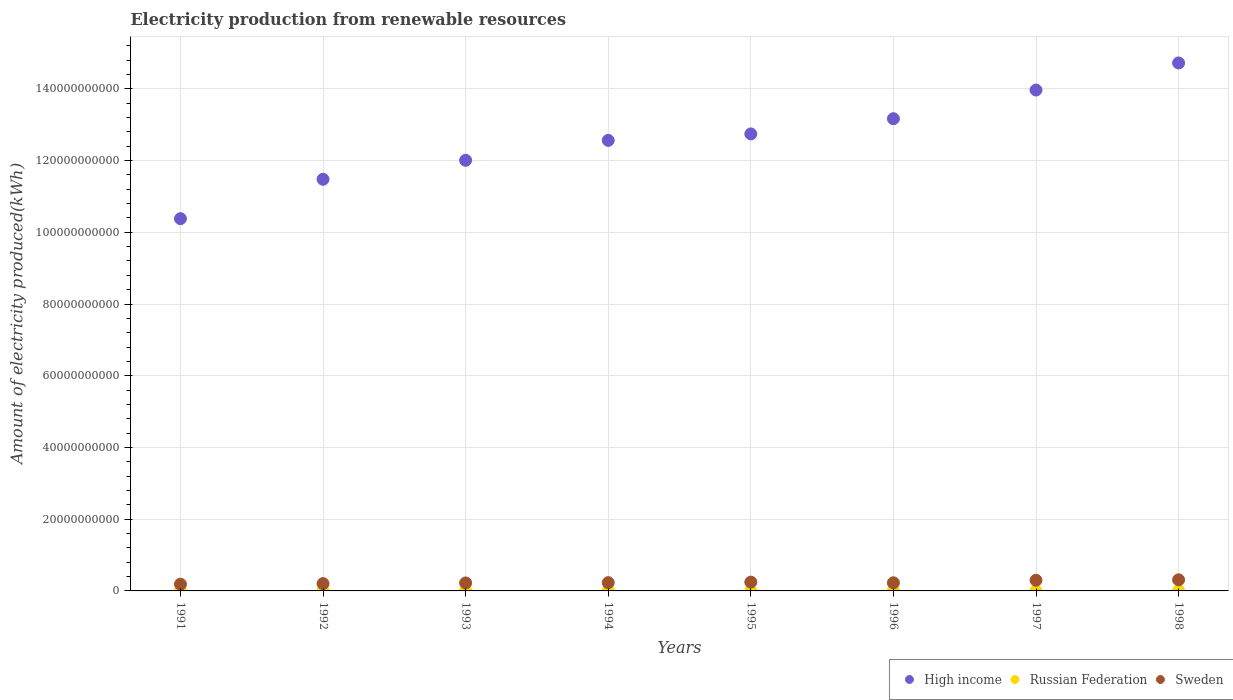Is the number of dotlines equal to the number of legend labels?
Offer a terse response. Yes. What is the amount of electricity produced in Russian Federation in 1998?
Offer a terse response. 5.80e+07. Across all years, what is the maximum amount of electricity produced in Russian Federation?
Make the answer very short. 6.50e+07. Across all years, what is the minimum amount of electricity produced in Sweden?
Your answer should be compact. 1.87e+09. In which year was the amount of electricity produced in Russian Federation maximum?
Give a very brief answer. 1991. In which year was the amount of electricity produced in Russian Federation minimum?
Give a very brief answer. 1996. What is the total amount of electricity produced in Sweden in the graph?
Keep it short and to the point. 1.92e+1. What is the difference between the amount of electricity produced in High income in 1992 and that in 1995?
Give a very brief answer. -1.27e+1. What is the difference between the amount of electricity produced in Russian Federation in 1995 and the amount of electricity produced in Sweden in 1996?
Give a very brief answer. -2.20e+09. What is the average amount of electricity produced in Sweden per year?
Provide a succinct answer. 2.40e+09. In the year 1998, what is the difference between the amount of electricity produced in Russian Federation and amount of electricity produced in High income?
Make the answer very short. -1.47e+11. In how many years, is the amount of electricity produced in Russian Federation greater than 16000000000 kWh?
Keep it short and to the point. 0. What is the ratio of the amount of electricity produced in Sweden in 1997 to that in 1998?
Ensure brevity in your answer.  0.96. Is the amount of electricity produced in Russian Federation in 1993 less than that in 1996?
Provide a short and direct response. No. What is the difference between the highest and the second highest amount of electricity produced in High income?
Your answer should be very brief. 7.55e+09. What is the difference between the highest and the lowest amount of electricity produced in Sweden?
Your response must be concise. 1.22e+09. Is the sum of the amount of electricity produced in Sweden in 1993 and 1997 greater than the maximum amount of electricity produced in Russian Federation across all years?
Your response must be concise. Yes. Where does the legend appear in the graph?
Provide a succinct answer. Bottom right. What is the title of the graph?
Your answer should be compact. Electricity production from renewable resources. Does "Cabo Verde" appear as one of the legend labels in the graph?
Give a very brief answer. No. What is the label or title of the Y-axis?
Make the answer very short. Amount of electricity produced(kWh). What is the Amount of electricity produced(kWh) in High income in 1991?
Your response must be concise. 1.04e+11. What is the Amount of electricity produced(kWh) in Russian Federation in 1991?
Provide a short and direct response. 6.50e+07. What is the Amount of electricity produced(kWh) of Sweden in 1991?
Offer a very short reply. 1.87e+09. What is the Amount of electricity produced(kWh) of High income in 1992?
Provide a succinct answer. 1.15e+11. What is the Amount of electricity produced(kWh) of Russian Federation in 1992?
Offer a very short reply. 6.30e+07. What is the Amount of electricity produced(kWh) of Sweden in 1992?
Your answer should be compact. 2.04e+09. What is the Amount of electricity produced(kWh) in High income in 1993?
Provide a succinct answer. 1.20e+11. What is the Amount of electricity produced(kWh) in Russian Federation in 1993?
Your answer should be very brief. 6.00e+07. What is the Amount of electricity produced(kWh) in Sweden in 1993?
Keep it short and to the point. 2.22e+09. What is the Amount of electricity produced(kWh) in High income in 1994?
Make the answer very short. 1.26e+11. What is the Amount of electricity produced(kWh) in Russian Federation in 1994?
Give a very brief answer. 6.10e+07. What is the Amount of electricity produced(kWh) of Sweden in 1994?
Offer a terse response. 2.30e+09. What is the Amount of electricity produced(kWh) in High income in 1995?
Give a very brief answer. 1.27e+11. What is the Amount of electricity produced(kWh) of Russian Federation in 1995?
Your answer should be compact. 5.90e+07. What is the Amount of electricity produced(kWh) in Sweden in 1995?
Provide a succinct answer. 2.45e+09. What is the Amount of electricity produced(kWh) of High income in 1996?
Your answer should be very brief. 1.32e+11. What is the Amount of electricity produced(kWh) of Russian Federation in 1996?
Your answer should be very brief. 5.70e+07. What is the Amount of electricity produced(kWh) of Sweden in 1996?
Make the answer very short. 2.26e+09. What is the Amount of electricity produced(kWh) of High income in 1997?
Offer a very short reply. 1.40e+11. What is the Amount of electricity produced(kWh) of Russian Federation in 1997?
Make the answer very short. 5.70e+07. What is the Amount of electricity produced(kWh) in Sweden in 1997?
Ensure brevity in your answer.  2.98e+09. What is the Amount of electricity produced(kWh) of High income in 1998?
Offer a very short reply. 1.47e+11. What is the Amount of electricity produced(kWh) in Russian Federation in 1998?
Offer a very short reply. 5.80e+07. What is the Amount of electricity produced(kWh) in Sweden in 1998?
Keep it short and to the point. 3.10e+09. Across all years, what is the maximum Amount of electricity produced(kWh) of High income?
Give a very brief answer. 1.47e+11. Across all years, what is the maximum Amount of electricity produced(kWh) in Russian Federation?
Make the answer very short. 6.50e+07. Across all years, what is the maximum Amount of electricity produced(kWh) in Sweden?
Your answer should be very brief. 3.10e+09. Across all years, what is the minimum Amount of electricity produced(kWh) of High income?
Your answer should be compact. 1.04e+11. Across all years, what is the minimum Amount of electricity produced(kWh) in Russian Federation?
Your response must be concise. 5.70e+07. Across all years, what is the minimum Amount of electricity produced(kWh) of Sweden?
Offer a terse response. 1.87e+09. What is the total Amount of electricity produced(kWh) of High income in the graph?
Offer a terse response. 1.01e+12. What is the total Amount of electricity produced(kWh) of Russian Federation in the graph?
Give a very brief answer. 4.80e+08. What is the total Amount of electricity produced(kWh) of Sweden in the graph?
Make the answer very short. 1.92e+1. What is the difference between the Amount of electricity produced(kWh) of High income in 1991 and that in 1992?
Your response must be concise. -1.10e+1. What is the difference between the Amount of electricity produced(kWh) of Russian Federation in 1991 and that in 1992?
Make the answer very short. 2.00e+06. What is the difference between the Amount of electricity produced(kWh) in Sweden in 1991 and that in 1992?
Ensure brevity in your answer.  -1.68e+08. What is the difference between the Amount of electricity produced(kWh) of High income in 1991 and that in 1993?
Your answer should be very brief. -1.63e+1. What is the difference between the Amount of electricity produced(kWh) in Sweden in 1991 and that in 1993?
Keep it short and to the point. -3.47e+08. What is the difference between the Amount of electricity produced(kWh) of High income in 1991 and that in 1994?
Make the answer very short. -2.18e+1. What is the difference between the Amount of electricity produced(kWh) of Sweden in 1991 and that in 1994?
Make the answer very short. -4.29e+08. What is the difference between the Amount of electricity produced(kWh) in High income in 1991 and that in 1995?
Your answer should be very brief. -2.36e+1. What is the difference between the Amount of electricity produced(kWh) in Russian Federation in 1991 and that in 1995?
Your response must be concise. 6.00e+06. What is the difference between the Amount of electricity produced(kWh) in Sweden in 1991 and that in 1995?
Your answer should be very brief. -5.81e+08. What is the difference between the Amount of electricity produced(kWh) of High income in 1991 and that in 1996?
Make the answer very short. -2.79e+1. What is the difference between the Amount of electricity produced(kWh) of Sweden in 1991 and that in 1996?
Your answer should be very brief. -3.90e+08. What is the difference between the Amount of electricity produced(kWh) in High income in 1991 and that in 1997?
Your answer should be compact. -3.59e+1. What is the difference between the Amount of electricity produced(kWh) in Sweden in 1991 and that in 1997?
Your response must be concise. -1.10e+09. What is the difference between the Amount of electricity produced(kWh) in High income in 1991 and that in 1998?
Provide a succinct answer. -4.34e+1. What is the difference between the Amount of electricity produced(kWh) of Russian Federation in 1991 and that in 1998?
Give a very brief answer. 7.00e+06. What is the difference between the Amount of electricity produced(kWh) in Sweden in 1991 and that in 1998?
Your answer should be compact. -1.22e+09. What is the difference between the Amount of electricity produced(kWh) of High income in 1992 and that in 1993?
Give a very brief answer. -5.29e+09. What is the difference between the Amount of electricity produced(kWh) of Russian Federation in 1992 and that in 1993?
Keep it short and to the point. 3.00e+06. What is the difference between the Amount of electricity produced(kWh) of Sweden in 1992 and that in 1993?
Give a very brief answer. -1.79e+08. What is the difference between the Amount of electricity produced(kWh) of High income in 1992 and that in 1994?
Your answer should be compact. -1.08e+1. What is the difference between the Amount of electricity produced(kWh) of Russian Federation in 1992 and that in 1994?
Keep it short and to the point. 2.00e+06. What is the difference between the Amount of electricity produced(kWh) of Sweden in 1992 and that in 1994?
Offer a terse response. -2.61e+08. What is the difference between the Amount of electricity produced(kWh) of High income in 1992 and that in 1995?
Offer a terse response. -1.27e+1. What is the difference between the Amount of electricity produced(kWh) of Sweden in 1992 and that in 1995?
Give a very brief answer. -4.13e+08. What is the difference between the Amount of electricity produced(kWh) of High income in 1992 and that in 1996?
Give a very brief answer. -1.69e+1. What is the difference between the Amount of electricity produced(kWh) in Russian Federation in 1992 and that in 1996?
Offer a terse response. 6.00e+06. What is the difference between the Amount of electricity produced(kWh) in Sweden in 1992 and that in 1996?
Ensure brevity in your answer.  -2.22e+08. What is the difference between the Amount of electricity produced(kWh) of High income in 1992 and that in 1997?
Make the answer very short. -2.49e+1. What is the difference between the Amount of electricity produced(kWh) of Sweden in 1992 and that in 1997?
Keep it short and to the point. -9.36e+08. What is the difference between the Amount of electricity produced(kWh) in High income in 1992 and that in 1998?
Keep it short and to the point. -3.24e+1. What is the difference between the Amount of electricity produced(kWh) in Russian Federation in 1992 and that in 1998?
Offer a very short reply. 5.00e+06. What is the difference between the Amount of electricity produced(kWh) in Sweden in 1992 and that in 1998?
Provide a short and direct response. -1.06e+09. What is the difference between the Amount of electricity produced(kWh) of High income in 1993 and that in 1994?
Make the answer very short. -5.56e+09. What is the difference between the Amount of electricity produced(kWh) of Russian Federation in 1993 and that in 1994?
Give a very brief answer. -1.00e+06. What is the difference between the Amount of electricity produced(kWh) of Sweden in 1993 and that in 1994?
Ensure brevity in your answer.  -8.20e+07. What is the difference between the Amount of electricity produced(kWh) in High income in 1993 and that in 1995?
Keep it short and to the point. -7.36e+09. What is the difference between the Amount of electricity produced(kWh) of Sweden in 1993 and that in 1995?
Make the answer very short. -2.34e+08. What is the difference between the Amount of electricity produced(kWh) of High income in 1993 and that in 1996?
Provide a short and direct response. -1.16e+1. What is the difference between the Amount of electricity produced(kWh) in Sweden in 1993 and that in 1996?
Provide a short and direct response. -4.30e+07. What is the difference between the Amount of electricity produced(kWh) in High income in 1993 and that in 1997?
Provide a short and direct response. -1.96e+1. What is the difference between the Amount of electricity produced(kWh) of Sweden in 1993 and that in 1997?
Your answer should be compact. -7.57e+08. What is the difference between the Amount of electricity produced(kWh) in High income in 1993 and that in 1998?
Keep it short and to the point. -2.71e+1. What is the difference between the Amount of electricity produced(kWh) in Sweden in 1993 and that in 1998?
Provide a succinct answer. -8.78e+08. What is the difference between the Amount of electricity produced(kWh) of High income in 1994 and that in 1995?
Your answer should be compact. -1.80e+09. What is the difference between the Amount of electricity produced(kWh) of Sweden in 1994 and that in 1995?
Your answer should be compact. -1.52e+08. What is the difference between the Amount of electricity produced(kWh) in High income in 1994 and that in 1996?
Offer a terse response. -6.05e+09. What is the difference between the Amount of electricity produced(kWh) of Russian Federation in 1994 and that in 1996?
Your answer should be very brief. 4.00e+06. What is the difference between the Amount of electricity produced(kWh) in Sweden in 1994 and that in 1996?
Your answer should be very brief. 3.90e+07. What is the difference between the Amount of electricity produced(kWh) of High income in 1994 and that in 1997?
Your response must be concise. -1.40e+1. What is the difference between the Amount of electricity produced(kWh) of Russian Federation in 1994 and that in 1997?
Provide a succinct answer. 4.00e+06. What is the difference between the Amount of electricity produced(kWh) of Sweden in 1994 and that in 1997?
Your answer should be compact. -6.75e+08. What is the difference between the Amount of electricity produced(kWh) in High income in 1994 and that in 1998?
Provide a short and direct response. -2.16e+1. What is the difference between the Amount of electricity produced(kWh) in Russian Federation in 1994 and that in 1998?
Give a very brief answer. 3.00e+06. What is the difference between the Amount of electricity produced(kWh) in Sweden in 1994 and that in 1998?
Offer a very short reply. -7.96e+08. What is the difference between the Amount of electricity produced(kWh) of High income in 1995 and that in 1996?
Give a very brief answer. -4.24e+09. What is the difference between the Amount of electricity produced(kWh) of Sweden in 1995 and that in 1996?
Provide a succinct answer. 1.91e+08. What is the difference between the Amount of electricity produced(kWh) in High income in 1995 and that in 1997?
Your answer should be compact. -1.22e+1. What is the difference between the Amount of electricity produced(kWh) in Russian Federation in 1995 and that in 1997?
Provide a succinct answer. 2.00e+06. What is the difference between the Amount of electricity produced(kWh) of Sweden in 1995 and that in 1997?
Offer a very short reply. -5.23e+08. What is the difference between the Amount of electricity produced(kWh) in High income in 1995 and that in 1998?
Your answer should be compact. -1.98e+1. What is the difference between the Amount of electricity produced(kWh) of Sweden in 1995 and that in 1998?
Give a very brief answer. -6.44e+08. What is the difference between the Amount of electricity produced(kWh) in High income in 1996 and that in 1997?
Your response must be concise. -7.99e+09. What is the difference between the Amount of electricity produced(kWh) of Russian Federation in 1996 and that in 1997?
Your answer should be compact. 0. What is the difference between the Amount of electricity produced(kWh) in Sweden in 1996 and that in 1997?
Provide a succinct answer. -7.14e+08. What is the difference between the Amount of electricity produced(kWh) in High income in 1996 and that in 1998?
Your answer should be very brief. -1.55e+1. What is the difference between the Amount of electricity produced(kWh) in Russian Federation in 1996 and that in 1998?
Make the answer very short. -1.00e+06. What is the difference between the Amount of electricity produced(kWh) in Sweden in 1996 and that in 1998?
Your response must be concise. -8.35e+08. What is the difference between the Amount of electricity produced(kWh) of High income in 1997 and that in 1998?
Make the answer very short. -7.55e+09. What is the difference between the Amount of electricity produced(kWh) in Russian Federation in 1997 and that in 1998?
Make the answer very short. -1.00e+06. What is the difference between the Amount of electricity produced(kWh) in Sweden in 1997 and that in 1998?
Your answer should be compact. -1.21e+08. What is the difference between the Amount of electricity produced(kWh) of High income in 1991 and the Amount of electricity produced(kWh) of Russian Federation in 1992?
Your answer should be compact. 1.04e+11. What is the difference between the Amount of electricity produced(kWh) in High income in 1991 and the Amount of electricity produced(kWh) in Sweden in 1992?
Your answer should be very brief. 1.02e+11. What is the difference between the Amount of electricity produced(kWh) in Russian Federation in 1991 and the Amount of electricity produced(kWh) in Sweden in 1992?
Ensure brevity in your answer.  -1.98e+09. What is the difference between the Amount of electricity produced(kWh) in High income in 1991 and the Amount of electricity produced(kWh) in Russian Federation in 1993?
Offer a very short reply. 1.04e+11. What is the difference between the Amount of electricity produced(kWh) in High income in 1991 and the Amount of electricity produced(kWh) in Sweden in 1993?
Provide a succinct answer. 1.02e+11. What is the difference between the Amount of electricity produced(kWh) of Russian Federation in 1991 and the Amount of electricity produced(kWh) of Sweden in 1993?
Keep it short and to the point. -2.16e+09. What is the difference between the Amount of electricity produced(kWh) of High income in 1991 and the Amount of electricity produced(kWh) of Russian Federation in 1994?
Ensure brevity in your answer.  1.04e+11. What is the difference between the Amount of electricity produced(kWh) of High income in 1991 and the Amount of electricity produced(kWh) of Sweden in 1994?
Your response must be concise. 1.01e+11. What is the difference between the Amount of electricity produced(kWh) in Russian Federation in 1991 and the Amount of electricity produced(kWh) in Sweden in 1994?
Offer a terse response. -2.24e+09. What is the difference between the Amount of electricity produced(kWh) in High income in 1991 and the Amount of electricity produced(kWh) in Russian Federation in 1995?
Your answer should be compact. 1.04e+11. What is the difference between the Amount of electricity produced(kWh) in High income in 1991 and the Amount of electricity produced(kWh) in Sweden in 1995?
Provide a succinct answer. 1.01e+11. What is the difference between the Amount of electricity produced(kWh) of Russian Federation in 1991 and the Amount of electricity produced(kWh) of Sweden in 1995?
Give a very brief answer. -2.39e+09. What is the difference between the Amount of electricity produced(kWh) of High income in 1991 and the Amount of electricity produced(kWh) of Russian Federation in 1996?
Offer a terse response. 1.04e+11. What is the difference between the Amount of electricity produced(kWh) of High income in 1991 and the Amount of electricity produced(kWh) of Sweden in 1996?
Your response must be concise. 1.02e+11. What is the difference between the Amount of electricity produced(kWh) in Russian Federation in 1991 and the Amount of electricity produced(kWh) in Sweden in 1996?
Your answer should be compact. -2.20e+09. What is the difference between the Amount of electricity produced(kWh) in High income in 1991 and the Amount of electricity produced(kWh) in Russian Federation in 1997?
Ensure brevity in your answer.  1.04e+11. What is the difference between the Amount of electricity produced(kWh) in High income in 1991 and the Amount of electricity produced(kWh) in Sweden in 1997?
Provide a short and direct response. 1.01e+11. What is the difference between the Amount of electricity produced(kWh) of Russian Federation in 1991 and the Amount of electricity produced(kWh) of Sweden in 1997?
Your answer should be compact. -2.91e+09. What is the difference between the Amount of electricity produced(kWh) of High income in 1991 and the Amount of electricity produced(kWh) of Russian Federation in 1998?
Keep it short and to the point. 1.04e+11. What is the difference between the Amount of electricity produced(kWh) in High income in 1991 and the Amount of electricity produced(kWh) in Sweden in 1998?
Ensure brevity in your answer.  1.01e+11. What is the difference between the Amount of electricity produced(kWh) of Russian Federation in 1991 and the Amount of electricity produced(kWh) of Sweden in 1998?
Your answer should be compact. -3.03e+09. What is the difference between the Amount of electricity produced(kWh) of High income in 1992 and the Amount of electricity produced(kWh) of Russian Federation in 1993?
Provide a short and direct response. 1.15e+11. What is the difference between the Amount of electricity produced(kWh) in High income in 1992 and the Amount of electricity produced(kWh) in Sweden in 1993?
Your answer should be very brief. 1.13e+11. What is the difference between the Amount of electricity produced(kWh) of Russian Federation in 1992 and the Amount of electricity produced(kWh) of Sweden in 1993?
Your response must be concise. -2.16e+09. What is the difference between the Amount of electricity produced(kWh) of High income in 1992 and the Amount of electricity produced(kWh) of Russian Federation in 1994?
Offer a terse response. 1.15e+11. What is the difference between the Amount of electricity produced(kWh) of High income in 1992 and the Amount of electricity produced(kWh) of Sweden in 1994?
Provide a short and direct response. 1.12e+11. What is the difference between the Amount of electricity produced(kWh) in Russian Federation in 1992 and the Amount of electricity produced(kWh) in Sweden in 1994?
Keep it short and to the point. -2.24e+09. What is the difference between the Amount of electricity produced(kWh) in High income in 1992 and the Amount of electricity produced(kWh) in Russian Federation in 1995?
Offer a terse response. 1.15e+11. What is the difference between the Amount of electricity produced(kWh) in High income in 1992 and the Amount of electricity produced(kWh) in Sweden in 1995?
Keep it short and to the point. 1.12e+11. What is the difference between the Amount of electricity produced(kWh) of Russian Federation in 1992 and the Amount of electricity produced(kWh) of Sweden in 1995?
Your answer should be compact. -2.39e+09. What is the difference between the Amount of electricity produced(kWh) in High income in 1992 and the Amount of electricity produced(kWh) in Russian Federation in 1996?
Your response must be concise. 1.15e+11. What is the difference between the Amount of electricity produced(kWh) in High income in 1992 and the Amount of electricity produced(kWh) in Sweden in 1996?
Offer a terse response. 1.13e+11. What is the difference between the Amount of electricity produced(kWh) of Russian Federation in 1992 and the Amount of electricity produced(kWh) of Sweden in 1996?
Make the answer very short. -2.20e+09. What is the difference between the Amount of electricity produced(kWh) of High income in 1992 and the Amount of electricity produced(kWh) of Russian Federation in 1997?
Ensure brevity in your answer.  1.15e+11. What is the difference between the Amount of electricity produced(kWh) of High income in 1992 and the Amount of electricity produced(kWh) of Sweden in 1997?
Offer a very short reply. 1.12e+11. What is the difference between the Amount of electricity produced(kWh) of Russian Federation in 1992 and the Amount of electricity produced(kWh) of Sweden in 1997?
Give a very brief answer. -2.91e+09. What is the difference between the Amount of electricity produced(kWh) of High income in 1992 and the Amount of electricity produced(kWh) of Russian Federation in 1998?
Give a very brief answer. 1.15e+11. What is the difference between the Amount of electricity produced(kWh) in High income in 1992 and the Amount of electricity produced(kWh) in Sweden in 1998?
Your answer should be compact. 1.12e+11. What is the difference between the Amount of electricity produced(kWh) in Russian Federation in 1992 and the Amount of electricity produced(kWh) in Sweden in 1998?
Your answer should be compact. -3.04e+09. What is the difference between the Amount of electricity produced(kWh) of High income in 1993 and the Amount of electricity produced(kWh) of Russian Federation in 1994?
Provide a succinct answer. 1.20e+11. What is the difference between the Amount of electricity produced(kWh) of High income in 1993 and the Amount of electricity produced(kWh) of Sweden in 1994?
Give a very brief answer. 1.18e+11. What is the difference between the Amount of electricity produced(kWh) in Russian Federation in 1993 and the Amount of electricity produced(kWh) in Sweden in 1994?
Offer a very short reply. -2.24e+09. What is the difference between the Amount of electricity produced(kWh) in High income in 1993 and the Amount of electricity produced(kWh) in Russian Federation in 1995?
Your response must be concise. 1.20e+11. What is the difference between the Amount of electricity produced(kWh) of High income in 1993 and the Amount of electricity produced(kWh) of Sweden in 1995?
Your response must be concise. 1.18e+11. What is the difference between the Amount of electricity produced(kWh) of Russian Federation in 1993 and the Amount of electricity produced(kWh) of Sweden in 1995?
Offer a very short reply. -2.39e+09. What is the difference between the Amount of electricity produced(kWh) in High income in 1993 and the Amount of electricity produced(kWh) in Russian Federation in 1996?
Give a very brief answer. 1.20e+11. What is the difference between the Amount of electricity produced(kWh) in High income in 1993 and the Amount of electricity produced(kWh) in Sweden in 1996?
Provide a succinct answer. 1.18e+11. What is the difference between the Amount of electricity produced(kWh) of Russian Federation in 1993 and the Amount of electricity produced(kWh) of Sweden in 1996?
Provide a succinct answer. -2.20e+09. What is the difference between the Amount of electricity produced(kWh) in High income in 1993 and the Amount of electricity produced(kWh) in Russian Federation in 1997?
Your response must be concise. 1.20e+11. What is the difference between the Amount of electricity produced(kWh) of High income in 1993 and the Amount of electricity produced(kWh) of Sweden in 1997?
Give a very brief answer. 1.17e+11. What is the difference between the Amount of electricity produced(kWh) in Russian Federation in 1993 and the Amount of electricity produced(kWh) in Sweden in 1997?
Offer a very short reply. -2.92e+09. What is the difference between the Amount of electricity produced(kWh) of High income in 1993 and the Amount of electricity produced(kWh) of Russian Federation in 1998?
Provide a succinct answer. 1.20e+11. What is the difference between the Amount of electricity produced(kWh) in High income in 1993 and the Amount of electricity produced(kWh) in Sweden in 1998?
Keep it short and to the point. 1.17e+11. What is the difference between the Amount of electricity produced(kWh) of Russian Federation in 1993 and the Amount of electricity produced(kWh) of Sweden in 1998?
Give a very brief answer. -3.04e+09. What is the difference between the Amount of electricity produced(kWh) of High income in 1994 and the Amount of electricity produced(kWh) of Russian Federation in 1995?
Your answer should be compact. 1.26e+11. What is the difference between the Amount of electricity produced(kWh) in High income in 1994 and the Amount of electricity produced(kWh) in Sweden in 1995?
Your answer should be compact. 1.23e+11. What is the difference between the Amount of electricity produced(kWh) of Russian Federation in 1994 and the Amount of electricity produced(kWh) of Sweden in 1995?
Make the answer very short. -2.39e+09. What is the difference between the Amount of electricity produced(kWh) of High income in 1994 and the Amount of electricity produced(kWh) of Russian Federation in 1996?
Make the answer very short. 1.26e+11. What is the difference between the Amount of electricity produced(kWh) of High income in 1994 and the Amount of electricity produced(kWh) of Sweden in 1996?
Offer a terse response. 1.23e+11. What is the difference between the Amount of electricity produced(kWh) of Russian Federation in 1994 and the Amount of electricity produced(kWh) of Sweden in 1996?
Your answer should be compact. -2.20e+09. What is the difference between the Amount of electricity produced(kWh) of High income in 1994 and the Amount of electricity produced(kWh) of Russian Federation in 1997?
Offer a terse response. 1.26e+11. What is the difference between the Amount of electricity produced(kWh) in High income in 1994 and the Amount of electricity produced(kWh) in Sweden in 1997?
Ensure brevity in your answer.  1.23e+11. What is the difference between the Amount of electricity produced(kWh) in Russian Federation in 1994 and the Amount of electricity produced(kWh) in Sweden in 1997?
Your answer should be compact. -2.92e+09. What is the difference between the Amount of electricity produced(kWh) in High income in 1994 and the Amount of electricity produced(kWh) in Russian Federation in 1998?
Ensure brevity in your answer.  1.26e+11. What is the difference between the Amount of electricity produced(kWh) in High income in 1994 and the Amount of electricity produced(kWh) in Sweden in 1998?
Provide a succinct answer. 1.23e+11. What is the difference between the Amount of electricity produced(kWh) of Russian Federation in 1994 and the Amount of electricity produced(kWh) of Sweden in 1998?
Your answer should be very brief. -3.04e+09. What is the difference between the Amount of electricity produced(kWh) in High income in 1995 and the Amount of electricity produced(kWh) in Russian Federation in 1996?
Offer a very short reply. 1.27e+11. What is the difference between the Amount of electricity produced(kWh) of High income in 1995 and the Amount of electricity produced(kWh) of Sweden in 1996?
Provide a short and direct response. 1.25e+11. What is the difference between the Amount of electricity produced(kWh) in Russian Federation in 1995 and the Amount of electricity produced(kWh) in Sweden in 1996?
Your answer should be very brief. -2.20e+09. What is the difference between the Amount of electricity produced(kWh) of High income in 1995 and the Amount of electricity produced(kWh) of Russian Federation in 1997?
Offer a terse response. 1.27e+11. What is the difference between the Amount of electricity produced(kWh) of High income in 1995 and the Amount of electricity produced(kWh) of Sweden in 1997?
Make the answer very short. 1.24e+11. What is the difference between the Amount of electricity produced(kWh) of Russian Federation in 1995 and the Amount of electricity produced(kWh) of Sweden in 1997?
Your answer should be compact. -2.92e+09. What is the difference between the Amount of electricity produced(kWh) in High income in 1995 and the Amount of electricity produced(kWh) in Russian Federation in 1998?
Keep it short and to the point. 1.27e+11. What is the difference between the Amount of electricity produced(kWh) of High income in 1995 and the Amount of electricity produced(kWh) of Sweden in 1998?
Give a very brief answer. 1.24e+11. What is the difference between the Amount of electricity produced(kWh) in Russian Federation in 1995 and the Amount of electricity produced(kWh) in Sweden in 1998?
Offer a terse response. -3.04e+09. What is the difference between the Amount of electricity produced(kWh) of High income in 1996 and the Amount of electricity produced(kWh) of Russian Federation in 1997?
Keep it short and to the point. 1.32e+11. What is the difference between the Amount of electricity produced(kWh) in High income in 1996 and the Amount of electricity produced(kWh) in Sweden in 1997?
Offer a terse response. 1.29e+11. What is the difference between the Amount of electricity produced(kWh) in Russian Federation in 1996 and the Amount of electricity produced(kWh) in Sweden in 1997?
Give a very brief answer. -2.92e+09. What is the difference between the Amount of electricity produced(kWh) in High income in 1996 and the Amount of electricity produced(kWh) in Russian Federation in 1998?
Your response must be concise. 1.32e+11. What is the difference between the Amount of electricity produced(kWh) of High income in 1996 and the Amount of electricity produced(kWh) of Sweden in 1998?
Offer a terse response. 1.29e+11. What is the difference between the Amount of electricity produced(kWh) of Russian Federation in 1996 and the Amount of electricity produced(kWh) of Sweden in 1998?
Provide a short and direct response. -3.04e+09. What is the difference between the Amount of electricity produced(kWh) of High income in 1997 and the Amount of electricity produced(kWh) of Russian Federation in 1998?
Offer a terse response. 1.40e+11. What is the difference between the Amount of electricity produced(kWh) in High income in 1997 and the Amount of electricity produced(kWh) in Sweden in 1998?
Provide a short and direct response. 1.37e+11. What is the difference between the Amount of electricity produced(kWh) in Russian Federation in 1997 and the Amount of electricity produced(kWh) in Sweden in 1998?
Offer a very short reply. -3.04e+09. What is the average Amount of electricity produced(kWh) in High income per year?
Your answer should be very brief. 1.26e+11. What is the average Amount of electricity produced(kWh) of Russian Federation per year?
Your response must be concise. 6.00e+07. What is the average Amount of electricity produced(kWh) of Sweden per year?
Offer a terse response. 2.40e+09. In the year 1991, what is the difference between the Amount of electricity produced(kWh) of High income and Amount of electricity produced(kWh) of Russian Federation?
Provide a short and direct response. 1.04e+11. In the year 1991, what is the difference between the Amount of electricity produced(kWh) of High income and Amount of electricity produced(kWh) of Sweden?
Your response must be concise. 1.02e+11. In the year 1991, what is the difference between the Amount of electricity produced(kWh) of Russian Federation and Amount of electricity produced(kWh) of Sweden?
Your answer should be compact. -1.81e+09. In the year 1992, what is the difference between the Amount of electricity produced(kWh) of High income and Amount of electricity produced(kWh) of Russian Federation?
Give a very brief answer. 1.15e+11. In the year 1992, what is the difference between the Amount of electricity produced(kWh) in High income and Amount of electricity produced(kWh) in Sweden?
Make the answer very short. 1.13e+11. In the year 1992, what is the difference between the Amount of electricity produced(kWh) in Russian Federation and Amount of electricity produced(kWh) in Sweden?
Keep it short and to the point. -1.98e+09. In the year 1993, what is the difference between the Amount of electricity produced(kWh) in High income and Amount of electricity produced(kWh) in Russian Federation?
Ensure brevity in your answer.  1.20e+11. In the year 1993, what is the difference between the Amount of electricity produced(kWh) of High income and Amount of electricity produced(kWh) of Sweden?
Ensure brevity in your answer.  1.18e+11. In the year 1993, what is the difference between the Amount of electricity produced(kWh) in Russian Federation and Amount of electricity produced(kWh) in Sweden?
Provide a short and direct response. -2.16e+09. In the year 1994, what is the difference between the Amount of electricity produced(kWh) in High income and Amount of electricity produced(kWh) in Russian Federation?
Ensure brevity in your answer.  1.26e+11. In the year 1994, what is the difference between the Amount of electricity produced(kWh) of High income and Amount of electricity produced(kWh) of Sweden?
Provide a succinct answer. 1.23e+11. In the year 1994, what is the difference between the Amount of electricity produced(kWh) in Russian Federation and Amount of electricity produced(kWh) in Sweden?
Offer a terse response. -2.24e+09. In the year 1995, what is the difference between the Amount of electricity produced(kWh) of High income and Amount of electricity produced(kWh) of Russian Federation?
Your answer should be compact. 1.27e+11. In the year 1995, what is the difference between the Amount of electricity produced(kWh) in High income and Amount of electricity produced(kWh) in Sweden?
Your response must be concise. 1.25e+11. In the year 1995, what is the difference between the Amount of electricity produced(kWh) in Russian Federation and Amount of electricity produced(kWh) in Sweden?
Your response must be concise. -2.40e+09. In the year 1996, what is the difference between the Amount of electricity produced(kWh) in High income and Amount of electricity produced(kWh) in Russian Federation?
Your answer should be very brief. 1.32e+11. In the year 1996, what is the difference between the Amount of electricity produced(kWh) in High income and Amount of electricity produced(kWh) in Sweden?
Make the answer very short. 1.29e+11. In the year 1996, what is the difference between the Amount of electricity produced(kWh) of Russian Federation and Amount of electricity produced(kWh) of Sweden?
Ensure brevity in your answer.  -2.21e+09. In the year 1997, what is the difference between the Amount of electricity produced(kWh) of High income and Amount of electricity produced(kWh) of Russian Federation?
Your answer should be very brief. 1.40e+11. In the year 1997, what is the difference between the Amount of electricity produced(kWh) of High income and Amount of electricity produced(kWh) of Sweden?
Offer a very short reply. 1.37e+11. In the year 1997, what is the difference between the Amount of electricity produced(kWh) in Russian Federation and Amount of electricity produced(kWh) in Sweden?
Provide a succinct answer. -2.92e+09. In the year 1998, what is the difference between the Amount of electricity produced(kWh) in High income and Amount of electricity produced(kWh) in Russian Federation?
Offer a very short reply. 1.47e+11. In the year 1998, what is the difference between the Amount of electricity produced(kWh) of High income and Amount of electricity produced(kWh) of Sweden?
Keep it short and to the point. 1.44e+11. In the year 1998, what is the difference between the Amount of electricity produced(kWh) in Russian Federation and Amount of electricity produced(kWh) in Sweden?
Offer a terse response. -3.04e+09. What is the ratio of the Amount of electricity produced(kWh) in High income in 1991 to that in 1992?
Provide a succinct answer. 0.9. What is the ratio of the Amount of electricity produced(kWh) in Russian Federation in 1991 to that in 1992?
Keep it short and to the point. 1.03. What is the ratio of the Amount of electricity produced(kWh) in Sweden in 1991 to that in 1992?
Ensure brevity in your answer.  0.92. What is the ratio of the Amount of electricity produced(kWh) in High income in 1991 to that in 1993?
Offer a very short reply. 0.86. What is the ratio of the Amount of electricity produced(kWh) in Russian Federation in 1991 to that in 1993?
Give a very brief answer. 1.08. What is the ratio of the Amount of electricity produced(kWh) of Sweden in 1991 to that in 1993?
Your response must be concise. 0.84. What is the ratio of the Amount of electricity produced(kWh) in High income in 1991 to that in 1994?
Offer a very short reply. 0.83. What is the ratio of the Amount of electricity produced(kWh) in Russian Federation in 1991 to that in 1994?
Your answer should be compact. 1.07. What is the ratio of the Amount of electricity produced(kWh) of Sweden in 1991 to that in 1994?
Give a very brief answer. 0.81. What is the ratio of the Amount of electricity produced(kWh) of High income in 1991 to that in 1995?
Ensure brevity in your answer.  0.81. What is the ratio of the Amount of electricity produced(kWh) in Russian Federation in 1991 to that in 1995?
Your answer should be very brief. 1.1. What is the ratio of the Amount of electricity produced(kWh) in Sweden in 1991 to that in 1995?
Your answer should be compact. 0.76. What is the ratio of the Amount of electricity produced(kWh) in High income in 1991 to that in 1996?
Provide a succinct answer. 0.79. What is the ratio of the Amount of electricity produced(kWh) in Russian Federation in 1991 to that in 1996?
Give a very brief answer. 1.14. What is the ratio of the Amount of electricity produced(kWh) of Sweden in 1991 to that in 1996?
Your answer should be compact. 0.83. What is the ratio of the Amount of electricity produced(kWh) in High income in 1991 to that in 1997?
Offer a very short reply. 0.74. What is the ratio of the Amount of electricity produced(kWh) in Russian Federation in 1991 to that in 1997?
Offer a very short reply. 1.14. What is the ratio of the Amount of electricity produced(kWh) in Sweden in 1991 to that in 1997?
Keep it short and to the point. 0.63. What is the ratio of the Amount of electricity produced(kWh) of High income in 1991 to that in 1998?
Make the answer very short. 0.71. What is the ratio of the Amount of electricity produced(kWh) of Russian Federation in 1991 to that in 1998?
Your response must be concise. 1.12. What is the ratio of the Amount of electricity produced(kWh) of Sweden in 1991 to that in 1998?
Your answer should be very brief. 0.6. What is the ratio of the Amount of electricity produced(kWh) of High income in 1992 to that in 1993?
Your response must be concise. 0.96. What is the ratio of the Amount of electricity produced(kWh) of Russian Federation in 1992 to that in 1993?
Offer a terse response. 1.05. What is the ratio of the Amount of electricity produced(kWh) of Sweden in 1992 to that in 1993?
Your answer should be compact. 0.92. What is the ratio of the Amount of electricity produced(kWh) of High income in 1992 to that in 1994?
Provide a short and direct response. 0.91. What is the ratio of the Amount of electricity produced(kWh) in Russian Federation in 1992 to that in 1994?
Offer a very short reply. 1.03. What is the ratio of the Amount of electricity produced(kWh) in Sweden in 1992 to that in 1994?
Offer a very short reply. 0.89. What is the ratio of the Amount of electricity produced(kWh) in High income in 1992 to that in 1995?
Give a very brief answer. 0.9. What is the ratio of the Amount of electricity produced(kWh) of Russian Federation in 1992 to that in 1995?
Provide a short and direct response. 1.07. What is the ratio of the Amount of electricity produced(kWh) of Sweden in 1992 to that in 1995?
Provide a succinct answer. 0.83. What is the ratio of the Amount of electricity produced(kWh) of High income in 1992 to that in 1996?
Offer a terse response. 0.87. What is the ratio of the Amount of electricity produced(kWh) of Russian Federation in 1992 to that in 1996?
Your response must be concise. 1.11. What is the ratio of the Amount of electricity produced(kWh) of Sweden in 1992 to that in 1996?
Give a very brief answer. 0.9. What is the ratio of the Amount of electricity produced(kWh) of High income in 1992 to that in 1997?
Your answer should be compact. 0.82. What is the ratio of the Amount of electricity produced(kWh) of Russian Federation in 1992 to that in 1997?
Provide a short and direct response. 1.11. What is the ratio of the Amount of electricity produced(kWh) of Sweden in 1992 to that in 1997?
Your answer should be compact. 0.69. What is the ratio of the Amount of electricity produced(kWh) in High income in 1992 to that in 1998?
Offer a very short reply. 0.78. What is the ratio of the Amount of electricity produced(kWh) in Russian Federation in 1992 to that in 1998?
Give a very brief answer. 1.09. What is the ratio of the Amount of electricity produced(kWh) in Sweden in 1992 to that in 1998?
Your response must be concise. 0.66. What is the ratio of the Amount of electricity produced(kWh) of High income in 1993 to that in 1994?
Your answer should be compact. 0.96. What is the ratio of the Amount of electricity produced(kWh) in Russian Federation in 1993 to that in 1994?
Provide a short and direct response. 0.98. What is the ratio of the Amount of electricity produced(kWh) of Sweden in 1993 to that in 1994?
Offer a terse response. 0.96. What is the ratio of the Amount of electricity produced(kWh) of High income in 1993 to that in 1995?
Offer a very short reply. 0.94. What is the ratio of the Amount of electricity produced(kWh) of Russian Federation in 1993 to that in 1995?
Your answer should be very brief. 1.02. What is the ratio of the Amount of electricity produced(kWh) of Sweden in 1993 to that in 1995?
Make the answer very short. 0.9. What is the ratio of the Amount of electricity produced(kWh) in High income in 1993 to that in 1996?
Your response must be concise. 0.91. What is the ratio of the Amount of electricity produced(kWh) in Russian Federation in 1993 to that in 1996?
Offer a terse response. 1.05. What is the ratio of the Amount of electricity produced(kWh) of Sweden in 1993 to that in 1996?
Offer a very short reply. 0.98. What is the ratio of the Amount of electricity produced(kWh) of High income in 1993 to that in 1997?
Make the answer very short. 0.86. What is the ratio of the Amount of electricity produced(kWh) in Russian Federation in 1993 to that in 1997?
Keep it short and to the point. 1.05. What is the ratio of the Amount of electricity produced(kWh) of Sweden in 1993 to that in 1997?
Your response must be concise. 0.75. What is the ratio of the Amount of electricity produced(kWh) of High income in 1993 to that in 1998?
Keep it short and to the point. 0.82. What is the ratio of the Amount of electricity produced(kWh) in Russian Federation in 1993 to that in 1998?
Make the answer very short. 1.03. What is the ratio of the Amount of electricity produced(kWh) in Sweden in 1993 to that in 1998?
Give a very brief answer. 0.72. What is the ratio of the Amount of electricity produced(kWh) of High income in 1994 to that in 1995?
Provide a short and direct response. 0.99. What is the ratio of the Amount of electricity produced(kWh) in Russian Federation in 1994 to that in 1995?
Provide a succinct answer. 1.03. What is the ratio of the Amount of electricity produced(kWh) in Sweden in 1994 to that in 1995?
Your answer should be compact. 0.94. What is the ratio of the Amount of electricity produced(kWh) in High income in 1994 to that in 1996?
Ensure brevity in your answer.  0.95. What is the ratio of the Amount of electricity produced(kWh) in Russian Federation in 1994 to that in 1996?
Ensure brevity in your answer.  1.07. What is the ratio of the Amount of electricity produced(kWh) in Sweden in 1994 to that in 1996?
Make the answer very short. 1.02. What is the ratio of the Amount of electricity produced(kWh) of High income in 1994 to that in 1997?
Give a very brief answer. 0.9. What is the ratio of the Amount of electricity produced(kWh) in Russian Federation in 1994 to that in 1997?
Ensure brevity in your answer.  1.07. What is the ratio of the Amount of electricity produced(kWh) in Sweden in 1994 to that in 1997?
Your answer should be very brief. 0.77. What is the ratio of the Amount of electricity produced(kWh) in High income in 1994 to that in 1998?
Offer a terse response. 0.85. What is the ratio of the Amount of electricity produced(kWh) in Russian Federation in 1994 to that in 1998?
Ensure brevity in your answer.  1.05. What is the ratio of the Amount of electricity produced(kWh) of Sweden in 1994 to that in 1998?
Provide a short and direct response. 0.74. What is the ratio of the Amount of electricity produced(kWh) of High income in 1995 to that in 1996?
Offer a terse response. 0.97. What is the ratio of the Amount of electricity produced(kWh) of Russian Federation in 1995 to that in 1996?
Make the answer very short. 1.04. What is the ratio of the Amount of electricity produced(kWh) of Sweden in 1995 to that in 1996?
Give a very brief answer. 1.08. What is the ratio of the Amount of electricity produced(kWh) of High income in 1995 to that in 1997?
Your response must be concise. 0.91. What is the ratio of the Amount of electricity produced(kWh) of Russian Federation in 1995 to that in 1997?
Provide a succinct answer. 1.04. What is the ratio of the Amount of electricity produced(kWh) of Sweden in 1995 to that in 1997?
Provide a short and direct response. 0.82. What is the ratio of the Amount of electricity produced(kWh) of High income in 1995 to that in 1998?
Offer a terse response. 0.87. What is the ratio of the Amount of electricity produced(kWh) in Russian Federation in 1995 to that in 1998?
Give a very brief answer. 1.02. What is the ratio of the Amount of electricity produced(kWh) of Sweden in 1995 to that in 1998?
Your response must be concise. 0.79. What is the ratio of the Amount of electricity produced(kWh) in High income in 1996 to that in 1997?
Offer a very short reply. 0.94. What is the ratio of the Amount of electricity produced(kWh) in Russian Federation in 1996 to that in 1997?
Offer a terse response. 1. What is the ratio of the Amount of electricity produced(kWh) in Sweden in 1996 to that in 1997?
Provide a short and direct response. 0.76. What is the ratio of the Amount of electricity produced(kWh) in High income in 1996 to that in 1998?
Make the answer very short. 0.89. What is the ratio of the Amount of electricity produced(kWh) of Russian Federation in 1996 to that in 1998?
Provide a short and direct response. 0.98. What is the ratio of the Amount of electricity produced(kWh) in Sweden in 1996 to that in 1998?
Provide a succinct answer. 0.73. What is the ratio of the Amount of electricity produced(kWh) in High income in 1997 to that in 1998?
Keep it short and to the point. 0.95. What is the ratio of the Amount of electricity produced(kWh) in Russian Federation in 1997 to that in 1998?
Keep it short and to the point. 0.98. What is the ratio of the Amount of electricity produced(kWh) in Sweden in 1997 to that in 1998?
Provide a short and direct response. 0.96. What is the difference between the highest and the second highest Amount of electricity produced(kWh) of High income?
Your answer should be compact. 7.55e+09. What is the difference between the highest and the second highest Amount of electricity produced(kWh) of Russian Federation?
Give a very brief answer. 2.00e+06. What is the difference between the highest and the second highest Amount of electricity produced(kWh) of Sweden?
Keep it short and to the point. 1.21e+08. What is the difference between the highest and the lowest Amount of electricity produced(kWh) of High income?
Provide a succinct answer. 4.34e+1. What is the difference between the highest and the lowest Amount of electricity produced(kWh) in Russian Federation?
Your response must be concise. 8.00e+06. What is the difference between the highest and the lowest Amount of electricity produced(kWh) of Sweden?
Offer a terse response. 1.22e+09. 